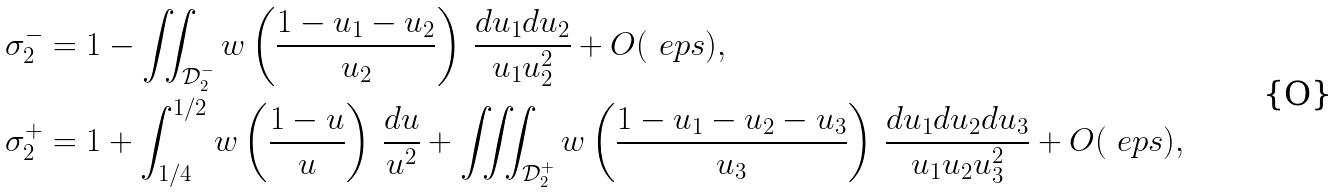Convert formula to latex. <formula><loc_0><loc_0><loc_500><loc_500>\sigma _ { 2 } ^ { - } & = 1 - \iint _ { \mathcal { D } _ { 2 } ^ { - } } w \left ( \frac { 1 - u _ { 1 } - u _ { 2 } } { u _ { 2 } } \right ) \, \frac { d u _ { 1 } d u _ { 2 } } { u _ { 1 } u _ { 2 } ^ { 2 } } + O ( \ e p s ) , \\ \sigma _ { 2 } ^ { + } & = 1 + \int _ { 1 / 4 } ^ { 1 / 2 } w \left ( \frac { 1 - u } { u } \right ) \, \frac { d u } { u ^ { 2 } } + \iiint _ { \mathcal { D } _ { 2 } ^ { + } } w \left ( \frac { 1 - u _ { 1 } - u _ { 2 } - u _ { 3 } } { u _ { 3 } } \right ) \, \frac { d u _ { 1 } d u _ { 2 } d u _ { 3 } } { u _ { 1 } u _ { 2 } u _ { 3 } ^ { 2 } } + O ( \ e p s ) , \\</formula> 